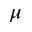<formula> <loc_0><loc_0><loc_500><loc_500>\mu</formula> 